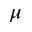<formula> <loc_0><loc_0><loc_500><loc_500>\mu</formula> 